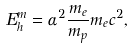Convert formula to latex. <formula><loc_0><loc_0><loc_500><loc_500>E ^ { m } _ { h } = \alpha ^ { 2 } \frac { m _ { e } } { m _ { p } } m _ { e } c ^ { 2 } ,</formula> 